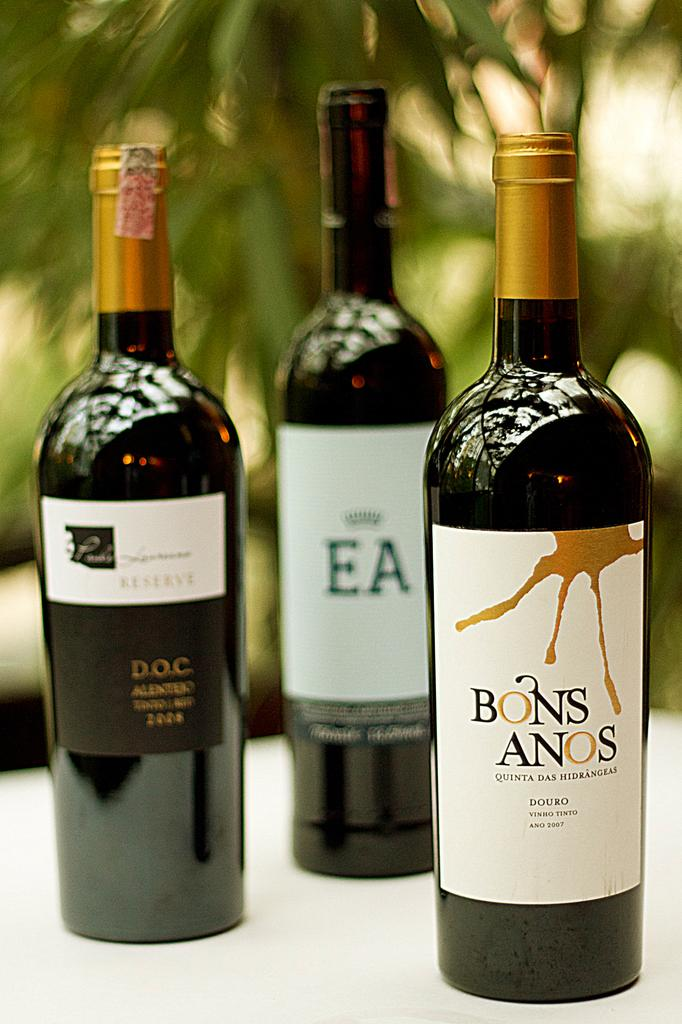How many bottles are visible in the image? There are three bottles in the image. What feature do the bottles have in common? The bottles have labels. What information can be found on the labels? There is writing on the labels. How many rabbits can be seen playing in harmony in the image? There are no rabbits or any indication of harmony in the image; it features three bottles with labels. 